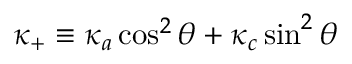Convert formula to latex. <formula><loc_0><loc_0><loc_500><loc_500>\kappa _ { + } \equiv \kappa _ { a } \cos ^ { 2 } \theta + \kappa _ { c } \sin ^ { 2 } \theta</formula> 